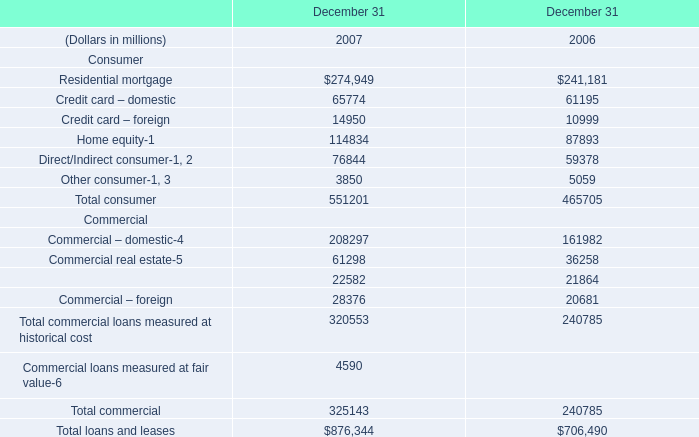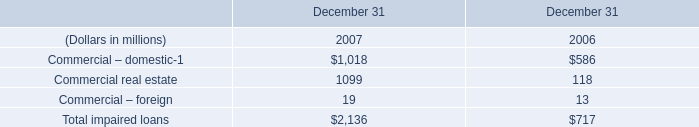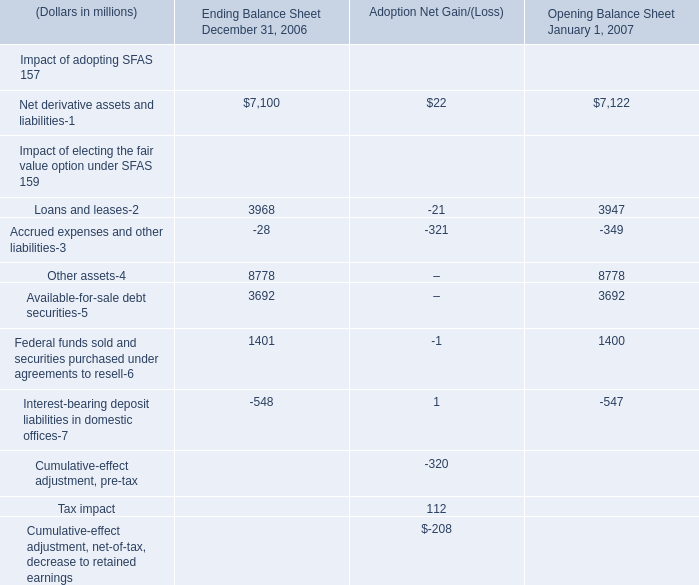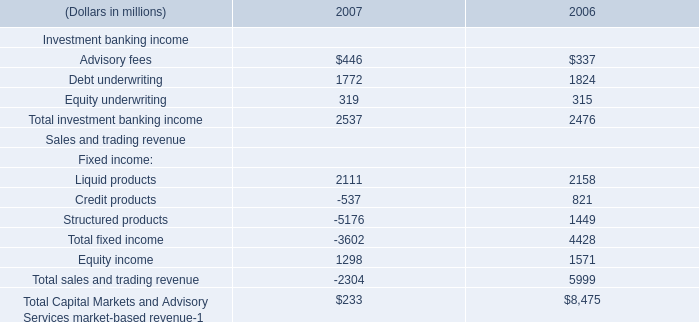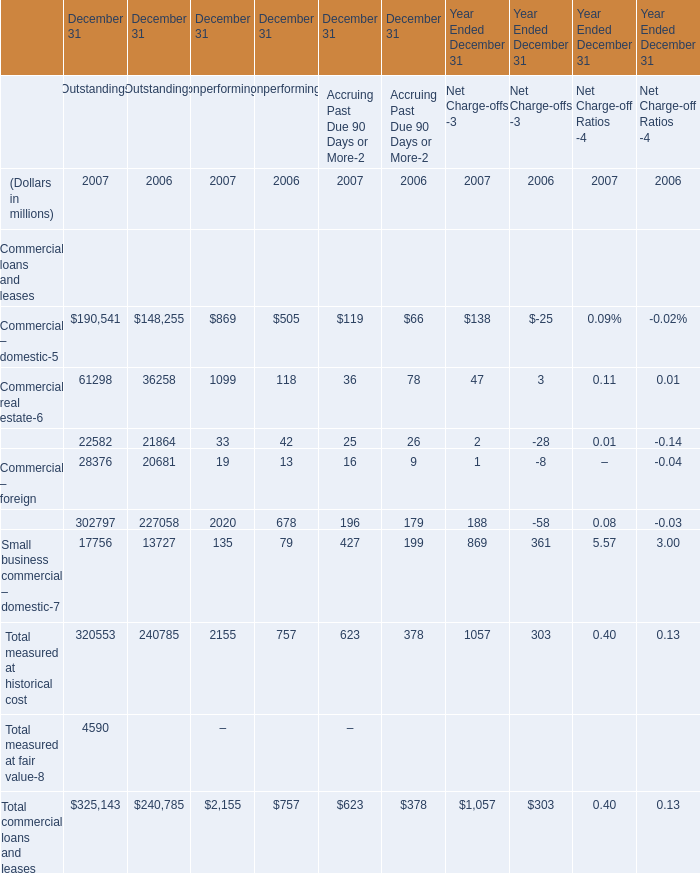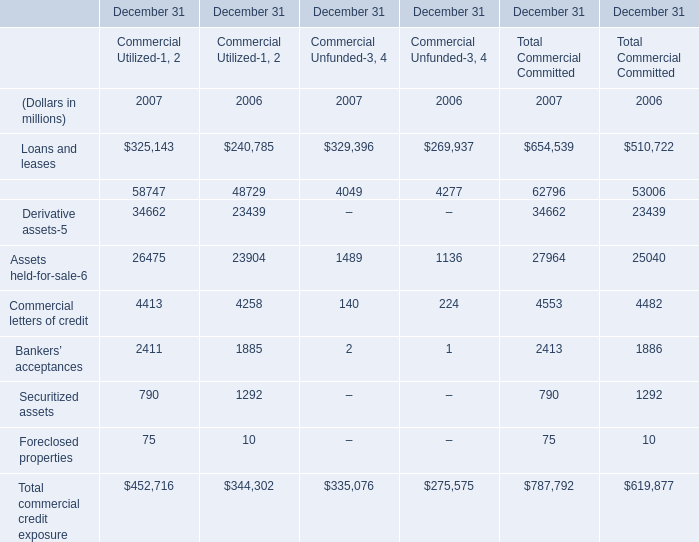What is the sum of Commercial real estate of December 31 Outstandings 2006, Debt underwriting of 2006, and Total investment banking income of 2006 ? 
Computations: ((36258.0 + 1824.0) + 2476.0)
Answer: 40558.0. 